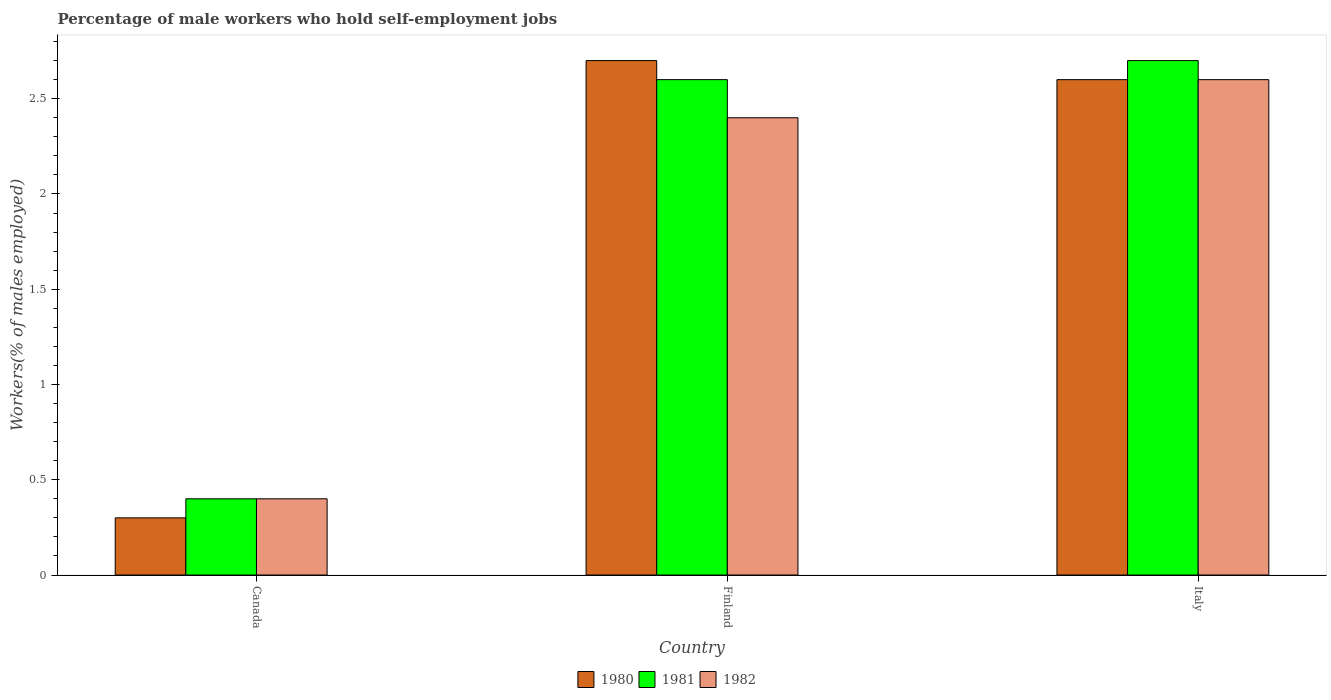How many bars are there on the 3rd tick from the left?
Keep it short and to the point. 3. How many bars are there on the 1st tick from the right?
Offer a terse response. 3. What is the percentage of self-employed male workers in 1980 in Canada?
Your answer should be very brief. 0.3. Across all countries, what is the maximum percentage of self-employed male workers in 1981?
Provide a short and direct response. 2.7. Across all countries, what is the minimum percentage of self-employed male workers in 1981?
Give a very brief answer. 0.4. In which country was the percentage of self-employed male workers in 1982 minimum?
Give a very brief answer. Canada. What is the total percentage of self-employed male workers in 1981 in the graph?
Give a very brief answer. 5.7. What is the difference between the percentage of self-employed male workers in 1981 in Canada and that in Italy?
Your answer should be very brief. -2.3. What is the difference between the percentage of self-employed male workers in 1982 in Italy and the percentage of self-employed male workers in 1981 in Canada?
Your answer should be compact. 2.2. What is the average percentage of self-employed male workers in 1981 per country?
Offer a very short reply. 1.9. What is the difference between the percentage of self-employed male workers of/in 1981 and percentage of self-employed male workers of/in 1982 in Finland?
Your response must be concise. 0.2. What is the ratio of the percentage of self-employed male workers in 1981 in Canada to that in Finland?
Your response must be concise. 0.15. Is the percentage of self-employed male workers in 1981 in Finland less than that in Italy?
Keep it short and to the point. Yes. Is the difference between the percentage of self-employed male workers in 1981 in Finland and Italy greater than the difference between the percentage of self-employed male workers in 1982 in Finland and Italy?
Offer a terse response. Yes. What is the difference between the highest and the second highest percentage of self-employed male workers in 1981?
Your answer should be compact. -2.3. What is the difference between the highest and the lowest percentage of self-employed male workers in 1980?
Your answer should be compact. 2.4. Is the sum of the percentage of self-employed male workers in 1982 in Canada and Italy greater than the maximum percentage of self-employed male workers in 1980 across all countries?
Give a very brief answer. Yes. What does the 2nd bar from the right in Finland represents?
Give a very brief answer. 1981. Is it the case that in every country, the sum of the percentage of self-employed male workers in 1982 and percentage of self-employed male workers in 1980 is greater than the percentage of self-employed male workers in 1981?
Offer a terse response. Yes. How many bars are there?
Give a very brief answer. 9. How many countries are there in the graph?
Ensure brevity in your answer.  3. What is the difference between two consecutive major ticks on the Y-axis?
Your answer should be very brief. 0.5. Does the graph contain any zero values?
Make the answer very short. No. Does the graph contain grids?
Offer a very short reply. No. How are the legend labels stacked?
Ensure brevity in your answer.  Horizontal. What is the title of the graph?
Keep it short and to the point. Percentage of male workers who hold self-employment jobs. What is the label or title of the X-axis?
Make the answer very short. Country. What is the label or title of the Y-axis?
Give a very brief answer. Workers(% of males employed). What is the Workers(% of males employed) in 1980 in Canada?
Your response must be concise. 0.3. What is the Workers(% of males employed) in 1981 in Canada?
Provide a short and direct response. 0.4. What is the Workers(% of males employed) of 1982 in Canada?
Give a very brief answer. 0.4. What is the Workers(% of males employed) in 1980 in Finland?
Provide a short and direct response. 2.7. What is the Workers(% of males employed) of 1981 in Finland?
Offer a very short reply. 2.6. What is the Workers(% of males employed) of 1982 in Finland?
Provide a succinct answer. 2.4. What is the Workers(% of males employed) of 1980 in Italy?
Offer a terse response. 2.6. What is the Workers(% of males employed) in 1981 in Italy?
Ensure brevity in your answer.  2.7. What is the Workers(% of males employed) in 1982 in Italy?
Provide a succinct answer. 2.6. Across all countries, what is the maximum Workers(% of males employed) in 1980?
Ensure brevity in your answer.  2.7. Across all countries, what is the maximum Workers(% of males employed) of 1981?
Provide a succinct answer. 2.7. Across all countries, what is the maximum Workers(% of males employed) in 1982?
Your response must be concise. 2.6. Across all countries, what is the minimum Workers(% of males employed) of 1980?
Keep it short and to the point. 0.3. Across all countries, what is the minimum Workers(% of males employed) of 1981?
Provide a short and direct response. 0.4. Across all countries, what is the minimum Workers(% of males employed) in 1982?
Make the answer very short. 0.4. What is the total Workers(% of males employed) of 1980 in the graph?
Provide a succinct answer. 5.6. What is the total Workers(% of males employed) of 1981 in the graph?
Provide a short and direct response. 5.7. What is the difference between the Workers(% of males employed) in 1981 in Canada and that in Finland?
Keep it short and to the point. -2.2. What is the difference between the Workers(% of males employed) in 1980 in Canada and that in Italy?
Give a very brief answer. -2.3. What is the difference between the Workers(% of males employed) in 1981 in Canada and that in Italy?
Ensure brevity in your answer.  -2.3. What is the difference between the Workers(% of males employed) in 1980 in Finland and that in Italy?
Give a very brief answer. 0.1. What is the difference between the Workers(% of males employed) of 1980 in Canada and the Workers(% of males employed) of 1981 in Finland?
Your response must be concise. -2.3. What is the difference between the Workers(% of males employed) of 1980 in Canada and the Workers(% of males employed) of 1982 in Finland?
Keep it short and to the point. -2.1. What is the difference between the Workers(% of males employed) of 1981 in Finland and the Workers(% of males employed) of 1982 in Italy?
Ensure brevity in your answer.  0. What is the average Workers(% of males employed) of 1980 per country?
Ensure brevity in your answer.  1.87. What is the average Workers(% of males employed) of 1981 per country?
Provide a succinct answer. 1.9. What is the average Workers(% of males employed) of 1982 per country?
Provide a succinct answer. 1.8. What is the difference between the Workers(% of males employed) of 1980 and Workers(% of males employed) of 1981 in Canada?
Your response must be concise. -0.1. What is the difference between the Workers(% of males employed) in 1980 and Workers(% of males employed) in 1982 in Finland?
Your answer should be compact. 0.3. What is the difference between the Workers(% of males employed) in 1981 and Workers(% of males employed) in 1982 in Finland?
Offer a very short reply. 0.2. What is the difference between the Workers(% of males employed) of 1981 and Workers(% of males employed) of 1982 in Italy?
Offer a very short reply. 0.1. What is the ratio of the Workers(% of males employed) in 1980 in Canada to that in Finland?
Offer a terse response. 0.11. What is the ratio of the Workers(% of males employed) in 1981 in Canada to that in Finland?
Your response must be concise. 0.15. What is the ratio of the Workers(% of males employed) in 1980 in Canada to that in Italy?
Offer a very short reply. 0.12. What is the ratio of the Workers(% of males employed) in 1981 in Canada to that in Italy?
Make the answer very short. 0.15. What is the ratio of the Workers(% of males employed) of 1982 in Canada to that in Italy?
Make the answer very short. 0.15. What is the ratio of the Workers(% of males employed) in 1980 in Finland to that in Italy?
Your response must be concise. 1.04. What is the ratio of the Workers(% of males employed) in 1982 in Finland to that in Italy?
Provide a short and direct response. 0.92. What is the difference between the highest and the second highest Workers(% of males employed) of 1981?
Provide a short and direct response. 0.1. What is the difference between the highest and the lowest Workers(% of males employed) of 1980?
Offer a very short reply. 2.4. What is the difference between the highest and the lowest Workers(% of males employed) in 1982?
Provide a succinct answer. 2.2. 